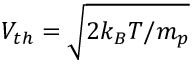<formula> <loc_0><loc_0><loc_500><loc_500>V _ { t h } = \sqrt { 2 k _ { B } T / m _ { p } }</formula> 